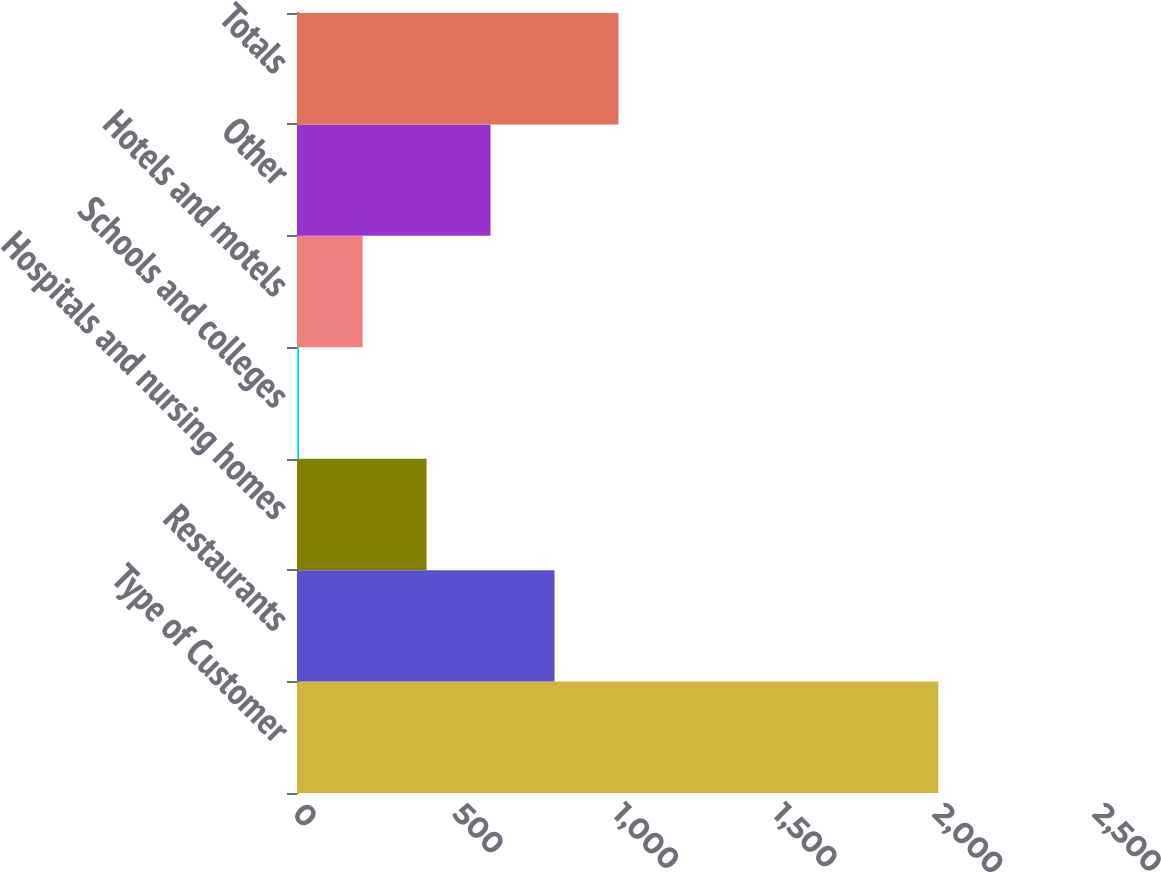Convert chart to OTSL. <chart><loc_0><loc_0><loc_500><loc_500><bar_chart><fcel>Type of Customer<fcel>Restaurants<fcel>Hospitals and nursing homes<fcel>Schools and colleges<fcel>Hotels and motels<fcel>Other<fcel>Totals<nl><fcel>2004<fcel>804.6<fcel>404.8<fcel>5<fcel>204.9<fcel>604.7<fcel>1004.5<nl></chart> 